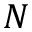<formula> <loc_0><loc_0><loc_500><loc_500>N</formula> 